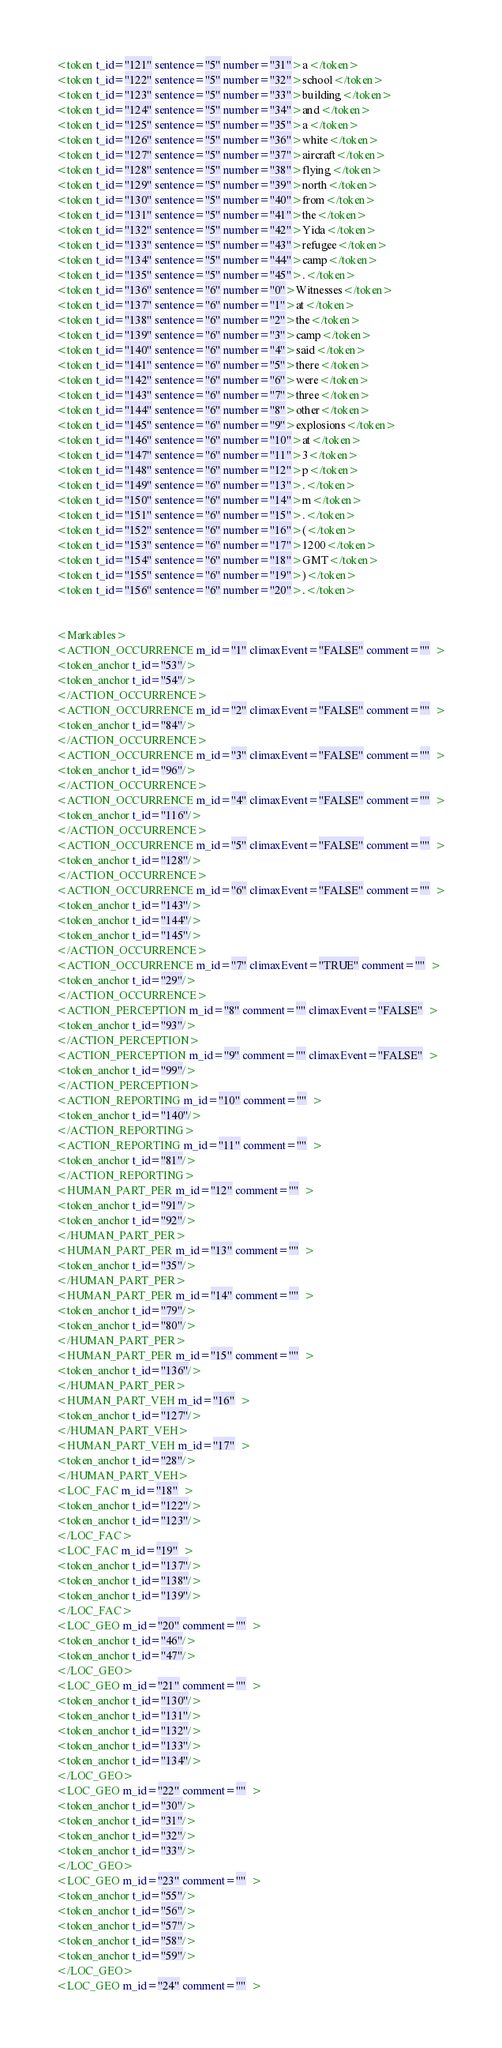<code> <loc_0><loc_0><loc_500><loc_500><_XML_><token t_id="121" sentence="5" number="31">a</token>
<token t_id="122" sentence="5" number="32">school</token>
<token t_id="123" sentence="5" number="33">building</token>
<token t_id="124" sentence="5" number="34">and</token>
<token t_id="125" sentence="5" number="35">a</token>
<token t_id="126" sentence="5" number="36">white</token>
<token t_id="127" sentence="5" number="37">aircraft</token>
<token t_id="128" sentence="5" number="38">flying</token>
<token t_id="129" sentence="5" number="39">north</token>
<token t_id="130" sentence="5" number="40">from</token>
<token t_id="131" sentence="5" number="41">the</token>
<token t_id="132" sentence="5" number="42">Yida</token>
<token t_id="133" sentence="5" number="43">refugee</token>
<token t_id="134" sentence="5" number="44">camp</token>
<token t_id="135" sentence="5" number="45">.</token>
<token t_id="136" sentence="6" number="0">Witnesses</token>
<token t_id="137" sentence="6" number="1">at</token>
<token t_id="138" sentence="6" number="2">the</token>
<token t_id="139" sentence="6" number="3">camp</token>
<token t_id="140" sentence="6" number="4">said</token>
<token t_id="141" sentence="6" number="5">there</token>
<token t_id="142" sentence="6" number="6">were</token>
<token t_id="143" sentence="6" number="7">three</token>
<token t_id="144" sentence="6" number="8">other</token>
<token t_id="145" sentence="6" number="9">explosions</token>
<token t_id="146" sentence="6" number="10">at</token>
<token t_id="147" sentence="6" number="11">3</token>
<token t_id="148" sentence="6" number="12">p</token>
<token t_id="149" sentence="6" number="13">.</token>
<token t_id="150" sentence="6" number="14">m</token>
<token t_id="151" sentence="6" number="15">.</token>
<token t_id="152" sentence="6" number="16">(</token>
<token t_id="153" sentence="6" number="17">1200</token>
<token t_id="154" sentence="6" number="18">GMT</token>
<token t_id="155" sentence="6" number="19">)</token>
<token t_id="156" sentence="6" number="20">.</token>


<Markables>
<ACTION_OCCURRENCE m_id="1" climaxEvent="FALSE" comment=""  >
<token_anchor t_id="53"/>
<token_anchor t_id="54"/>
</ACTION_OCCURRENCE>
<ACTION_OCCURRENCE m_id="2" climaxEvent="FALSE" comment=""  >
<token_anchor t_id="84"/>
</ACTION_OCCURRENCE>
<ACTION_OCCURRENCE m_id="3" climaxEvent="FALSE" comment=""  >
<token_anchor t_id="96"/>
</ACTION_OCCURRENCE>
<ACTION_OCCURRENCE m_id="4" climaxEvent="FALSE" comment=""  >
<token_anchor t_id="116"/>
</ACTION_OCCURRENCE>
<ACTION_OCCURRENCE m_id="5" climaxEvent="FALSE" comment=""  >
<token_anchor t_id="128"/>
</ACTION_OCCURRENCE>
<ACTION_OCCURRENCE m_id="6" climaxEvent="FALSE" comment=""  >
<token_anchor t_id="143"/>
<token_anchor t_id="144"/>
<token_anchor t_id="145"/>
</ACTION_OCCURRENCE>
<ACTION_OCCURRENCE m_id="7" climaxEvent="TRUE" comment=""  >
<token_anchor t_id="29"/>
</ACTION_OCCURRENCE>
<ACTION_PERCEPTION m_id="8" comment="" climaxEvent="FALSE"  >
<token_anchor t_id="93"/>
</ACTION_PERCEPTION>
<ACTION_PERCEPTION m_id="9" comment="" climaxEvent="FALSE"  >
<token_anchor t_id="99"/>
</ACTION_PERCEPTION>
<ACTION_REPORTING m_id="10" comment=""  >
<token_anchor t_id="140"/>
</ACTION_REPORTING>
<ACTION_REPORTING m_id="11" comment=""  >
<token_anchor t_id="81"/>
</ACTION_REPORTING>
<HUMAN_PART_PER m_id="12" comment=""  >
<token_anchor t_id="91"/>
<token_anchor t_id="92"/>
</HUMAN_PART_PER>
<HUMAN_PART_PER m_id="13" comment=""  >
<token_anchor t_id="35"/>
</HUMAN_PART_PER>
<HUMAN_PART_PER m_id="14" comment=""  >
<token_anchor t_id="79"/>
<token_anchor t_id="80"/>
</HUMAN_PART_PER>
<HUMAN_PART_PER m_id="15" comment=""  >
<token_anchor t_id="136"/>
</HUMAN_PART_PER>
<HUMAN_PART_VEH m_id="16"  >
<token_anchor t_id="127"/>
</HUMAN_PART_VEH>
<HUMAN_PART_VEH m_id="17"  >
<token_anchor t_id="28"/>
</HUMAN_PART_VEH>
<LOC_FAC m_id="18"  >
<token_anchor t_id="122"/>
<token_anchor t_id="123"/>
</LOC_FAC>
<LOC_FAC m_id="19"  >
<token_anchor t_id="137"/>
<token_anchor t_id="138"/>
<token_anchor t_id="139"/>
</LOC_FAC>
<LOC_GEO m_id="20" comment=""  >
<token_anchor t_id="46"/>
<token_anchor t_id="47"/>
</LOC_GEO>
<LOC_GEO m_id="21" comment=""  >
<token_anchor t_id="130"/>
<token_anchor t_id="131"/>
<token_anchor t_id="132"/>
<token_anchor t_id="133"/>
<token_anchor t_id="134"/>
</LOC_GEO>
<LOC_GEO m_id="22" comment=""  >
<token_anchor t_id="30"/>
<token_anchor t_id="31"/>
<token_anchor t_id="32"/>
<token_anchor t_id="33"/>
</LOC_GEO>
<LOC_GEO m_id="23" comment=""  >
<token_anchor t_id="55"/>
<token_anchor t_id="56"/>
<token_anchor t_id="57"/>
<token_anchor t_id="58"/>
<token_anchor t_id="59"/>
</LOC_GEO>
<LOC_GEO m_id="24" comment=""  ></code> 